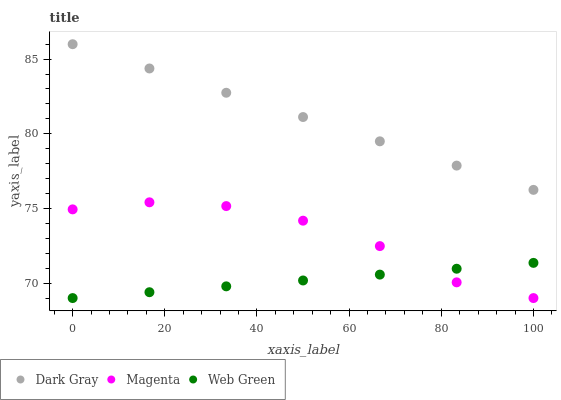Does Web Green have the minimum area under the curve?
Answer yes or no. Yes. Does Dark Gray have the maximum area under the curve?
Answer yes or no. Yes. Does Magenta have the minimum area under the curve?
Answer yes or no. No. Does Magenta have the maximum area under the curve?
Answer yes or no. No. Is Web Green the smoothest?
Answer yes or no. Yes. Is Magenta the roughest?
Answer yes or no. Yes. Is Magenta the smoothest?
Answer yes or no. No. Is Web Green the roughest?
Answer yes or no. No. Does Magenta have the lowest value?
Answer yes or no. Yes. Does Dark Gray have the highest value?
Answer yes or no. Yes. Does Magenta have the highest value?
Answer yes or no. No. Is Web Green less than Dark Gray?
Answer yes or no. Yes. Is Dark Gray greater than Magenta?
Answer yes or no. Yes. Does Web Green intersect Magenta?
Answer yes or no. Yes. Is Web Green less than Magenta?
Answer yes or no. No. Is Web Green greater than Magenta?
Answer yes or no. No. Does Web Green intersect Dark Gray?
Answer yes or no. No. 